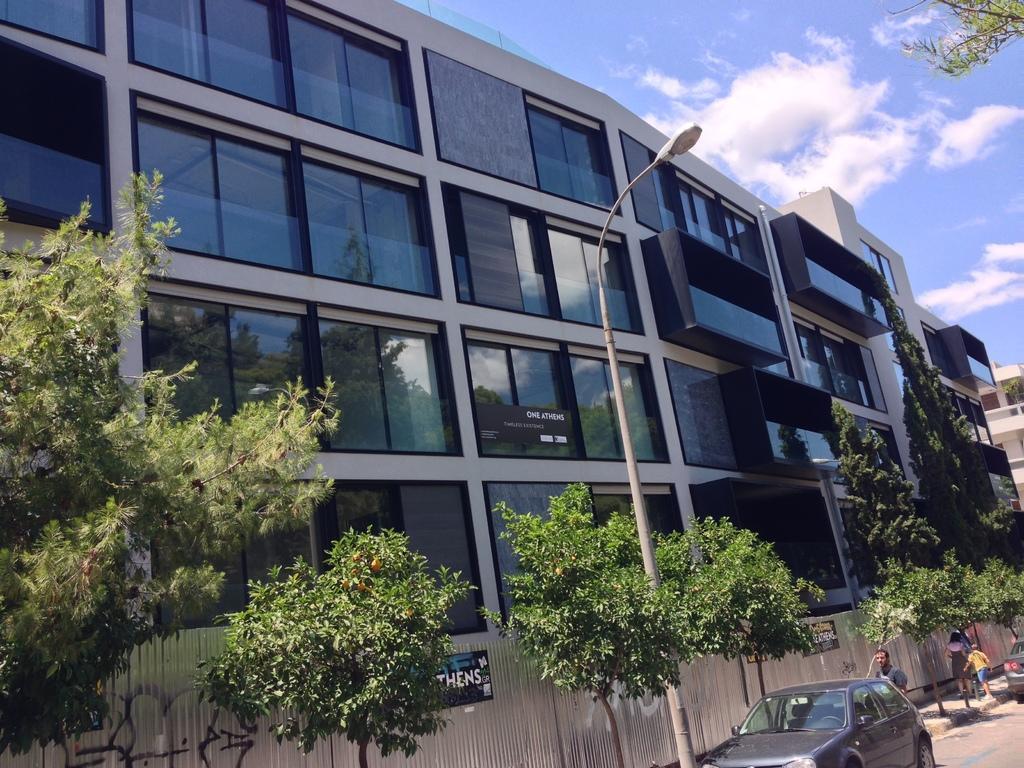Describe this image in one or two sentences. In this picture we can see there are vehicles on the road and behind the vehicles there are some people walking on the path. On the left side of the vehicle there are trees, a pole with light and buildings. Behind the buildings there is the sky. 